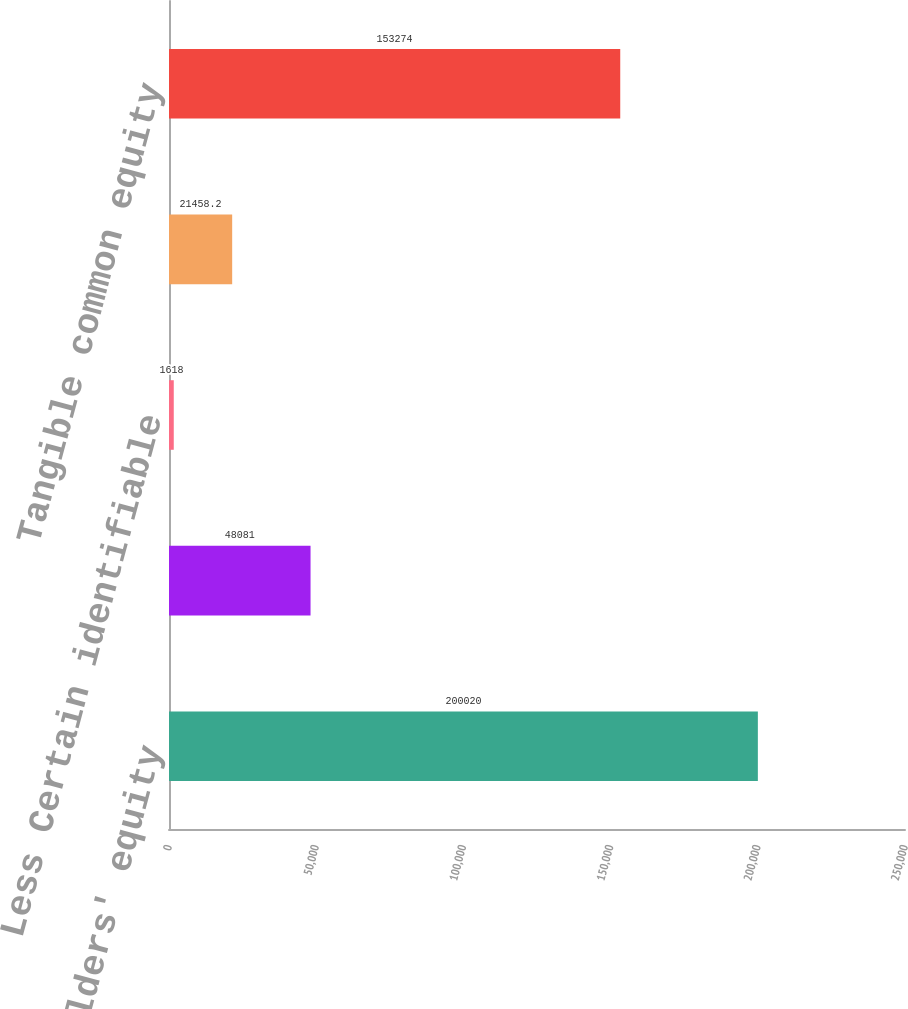Convert chart to OTSL. <chart><loc_0><loc_0><loc_500><loc_500><bar_chart><fcel>Common stockholders' equity<fcel>Less Goodwill<fcel>Less Certain identifiable<fcel>Add Deferred tax liabilities<fcel>Tangible common equity<nl><fcel>200020<fcel>48081<fcel>1618<fcel>21458.2<fcel>153274<nl></chart> 